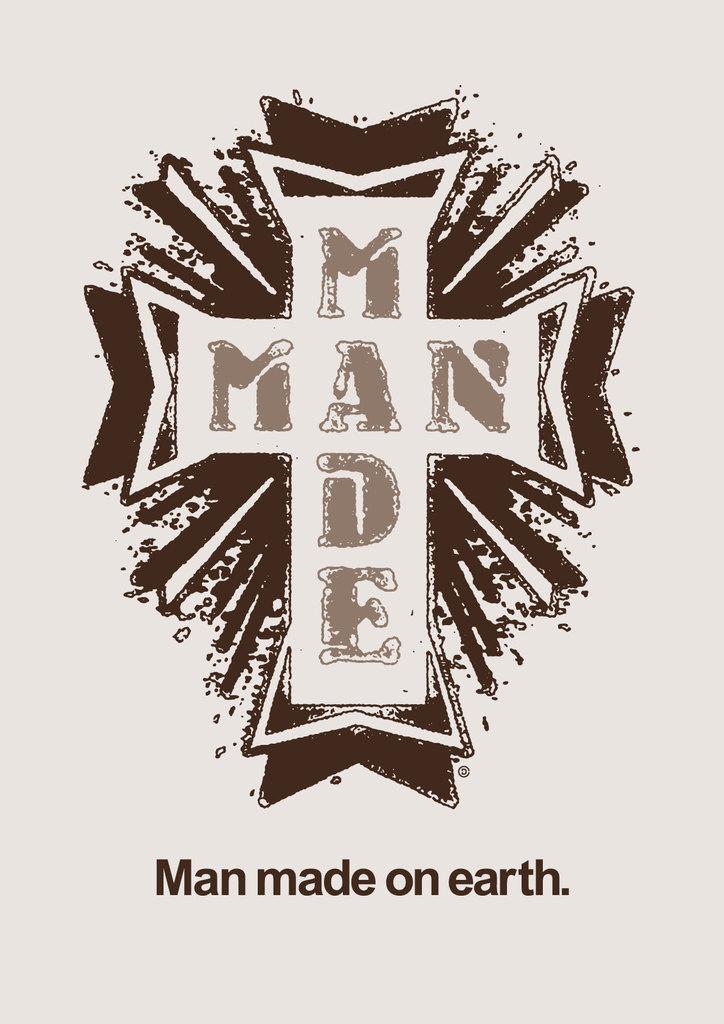What does the middle of the cross say?
Keep it short and to the point. Man made. Where was man made?
Give a very brief answer. On earth. 